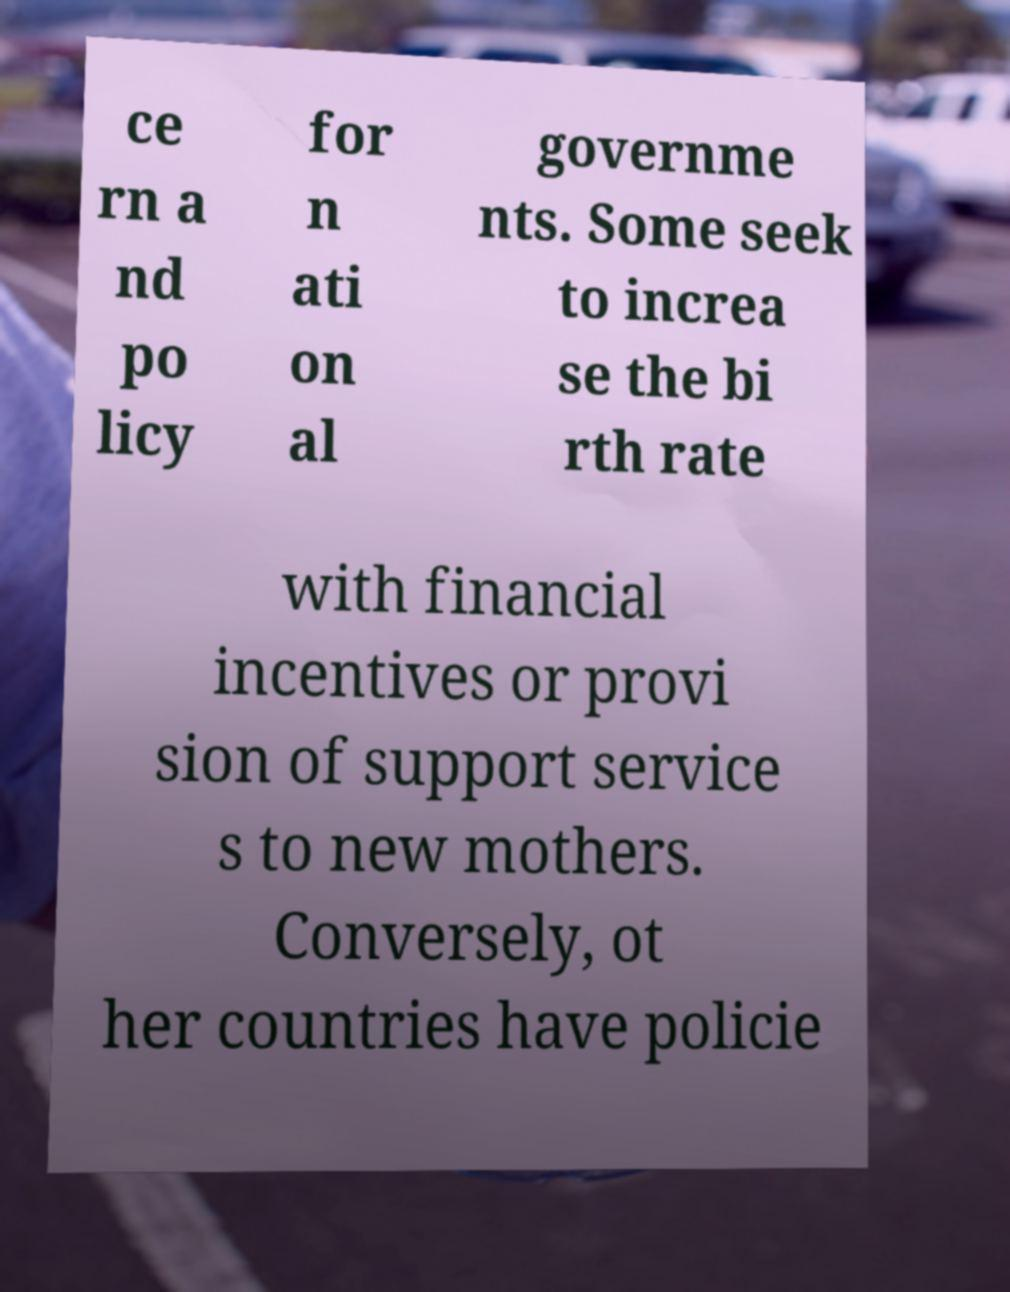Can you read and provide the text displayed in the image?This photo seems to have some interesting text. Can you extract and type it out for me? ce rn a nd po licy for n ati on al governme nts. Some seek to increa se the bi rth rate with financial incentives or provi sion of support service s to new mothers. Conversely, ot her countries have policie 